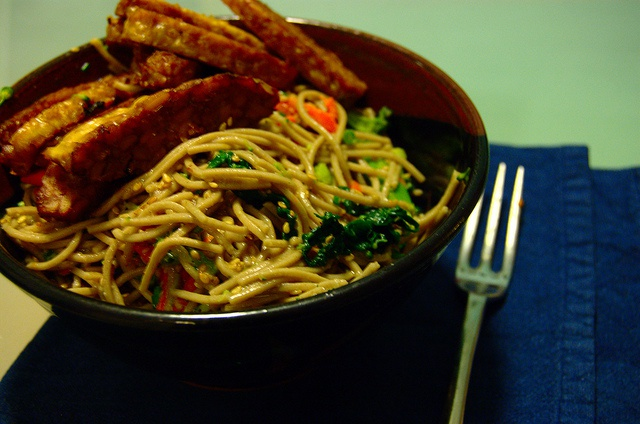Describe the objects in this image and their specific colors. I can see bowl in darkgray, black, maroon, and olive tones, hot dog in darkgray, black, maroon, olive, and orange tones, fork in darkgray, black, darkgreen, and beige tones, broccoli in darkgray, black, darkgreen, olive, and maroon tones, and carrot in darkgray, red, orange, and olive tones in this image. 